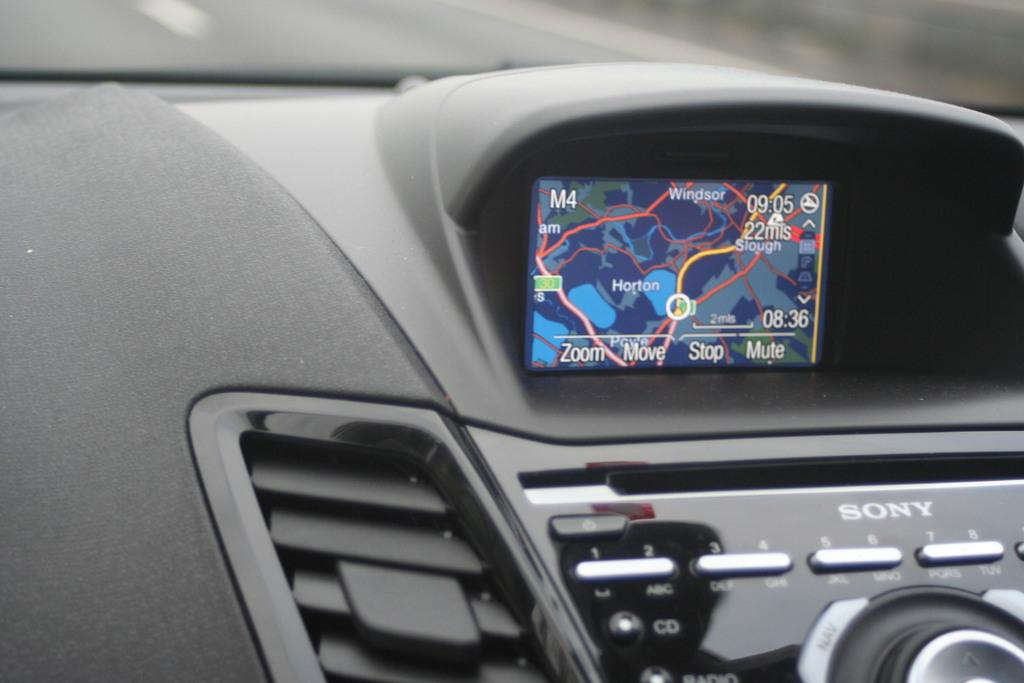What type of location is depicted in the image? The image is an inside view of a vehicle. What can be found at the bottom of the image? There are buttons at the bottom of the image. What is located at the top of the image? There is a screen at the top of the image. What information is displayed on the screen? Text is visible on the screen, and a map is also visible. What type of linen is draped over the steering wheel in the image? There is no linen present in the image, and the steering wheel is not covered. Can you see a spoon being used in the image? There is no spoon visible in the image. 